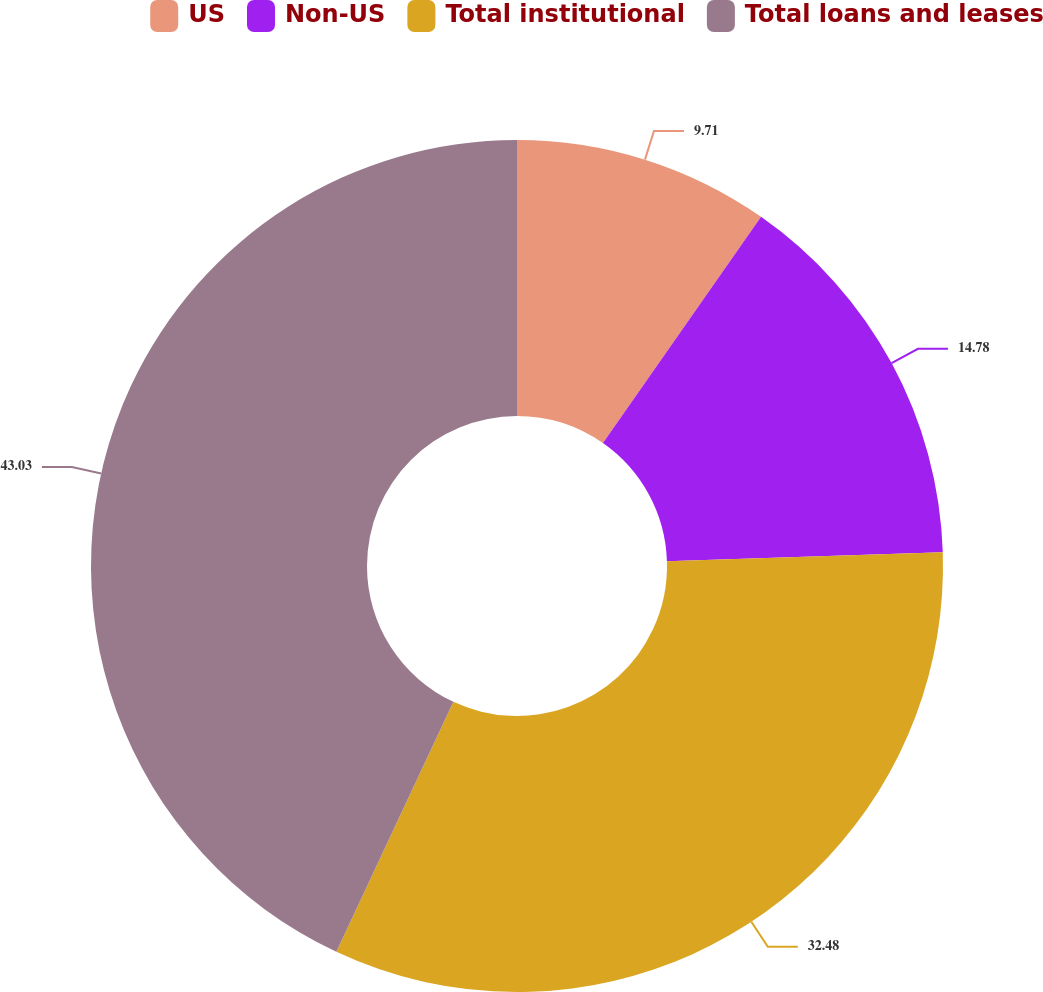Convert chart to OTSL. <chart><loc_0><loc_0><loc_500><loc_500><pie_chart><fcel>US<fcel>Non-US<fcel>Total institutional<fcel>Total loans and leases<nl><fcel>9.71%<fcel>14.78%<fcel>32.48%<fcel>43.03%<nl></chart> 